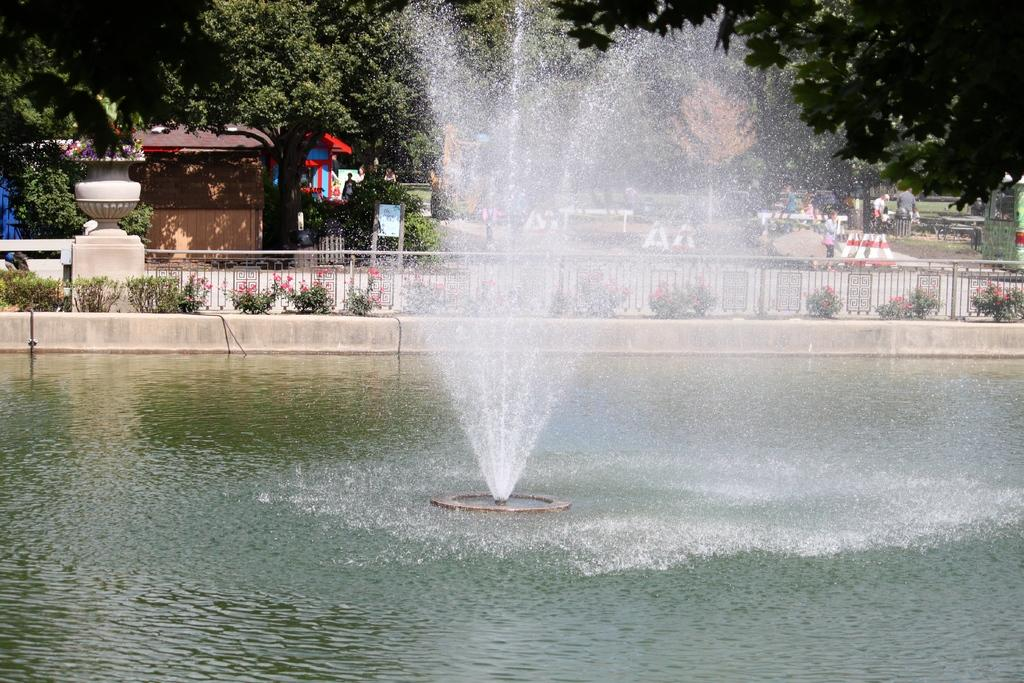What is the main feature of the image? There is a fountain in the image. What can be seen in the water? There is no specific detail about the water in the image. What type of vegetation is present in the image? There are plants and trees in the image. What type of structures are visible in the image? There are houses in the image. Are there any people in the image? Yes, there are people in the image. What type of camera is being used to take the picture of the fountain? There is no camera present in the image, as it is a photograph of the scene. What type of home is visible in the image? There is no specific detail about the houses in the image, so it is not possible to determine the type of home. 